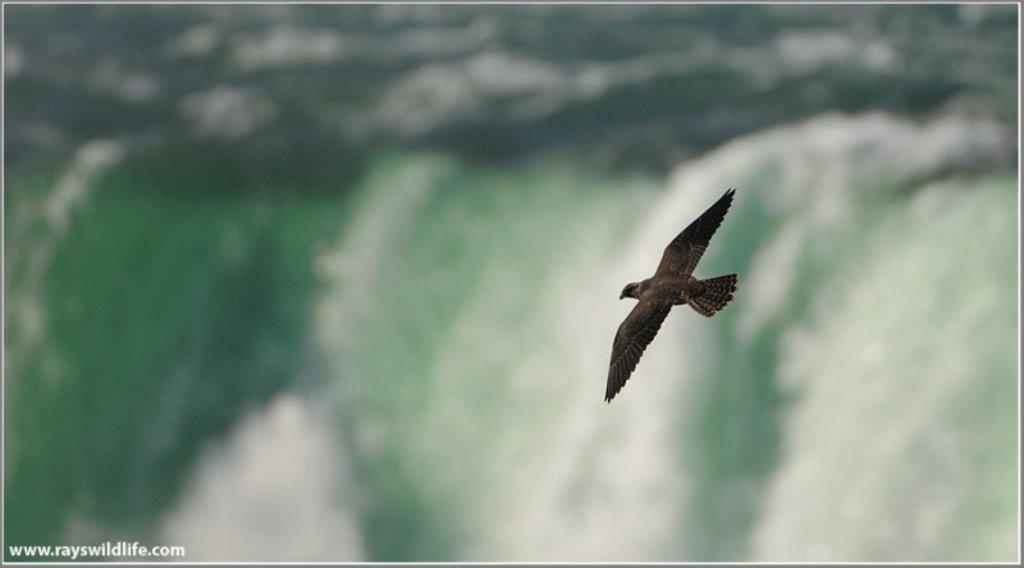Please provide a concise description of this image. In this image we can see a bird flying in the air. 